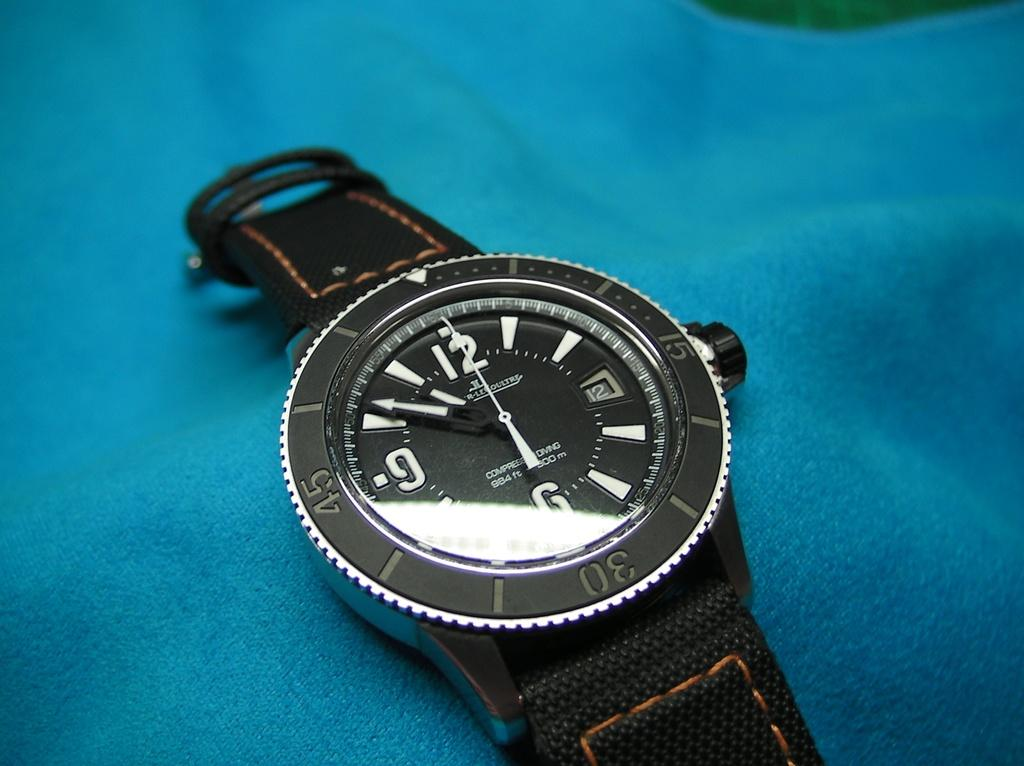<image>
Give a short and clear explanation of the subsequent image. A watch lying flat on a table with the time 10:51. 